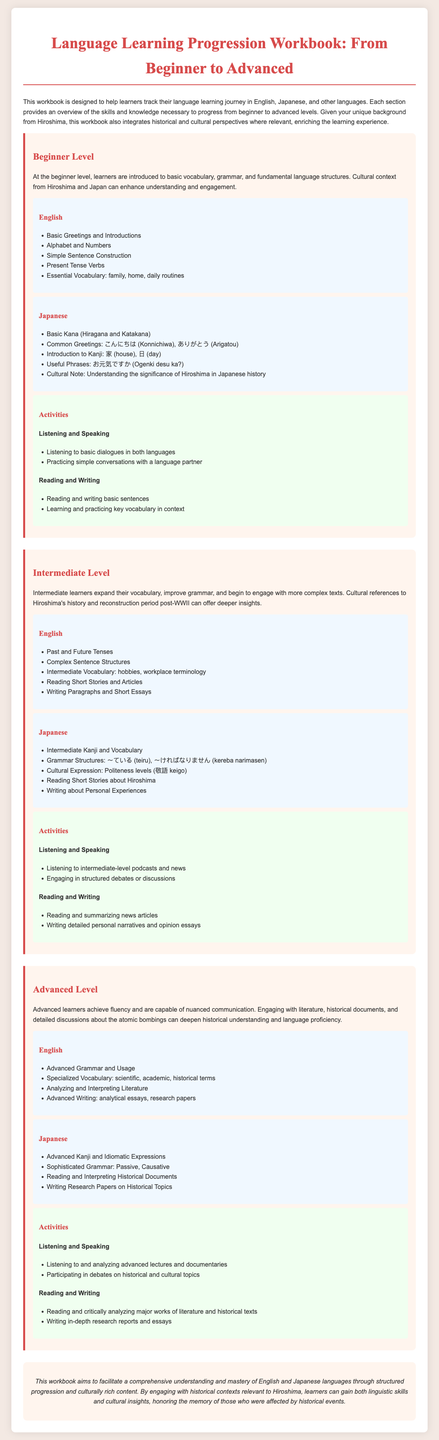What is the title of the workbook? The title of the workbook is provided in the header of the document.
Answer: Language Learning Progression Workbook: From Beginner to Advanced What language is primarily featured alongside English? The document mentions languages and their progression, specifically including Japanese.
Answer: Japanese What is the focus of the Beginner Level section? The Beginner Level section outlines the initial skills and vocabulary introduced to learners.
Answer: Basic vocabulary, grammar, and fundamental language structures Which kanji is introduced at the Beginner Level for Japanese? The document lists examples of kanji that beginners will learn; this is a specific character mentioned in the Japanese section.
Answer: 家 What cultural context is integrated into the language learning? The workbook aims to provide cultural insights that enrich the language learning experience.
Answer: Hiroshima's history What type of activities are suggested for Intermediate Level learners? The document describes various activities learners can do at the Intermediate Level.
Answer: Listening and engaging in structured debates Which grammar structures are introduced at the Intermediate Level in Japanese? The document lists specific grammar structures for learners at this level.
Answer: 〜ている, 〜ければなりません What are Advanced learners expected to analyze? The activities outlined for Advanced learners involve critical analysis of specific content.
Answer: Major works of literature and historical texts What is the overall aim of the workbook? The conclusion of the document summarizes the intentions behind its creation.
Answer: Facilitate a comprehensive understanding and mastery of English and Japanese languages 